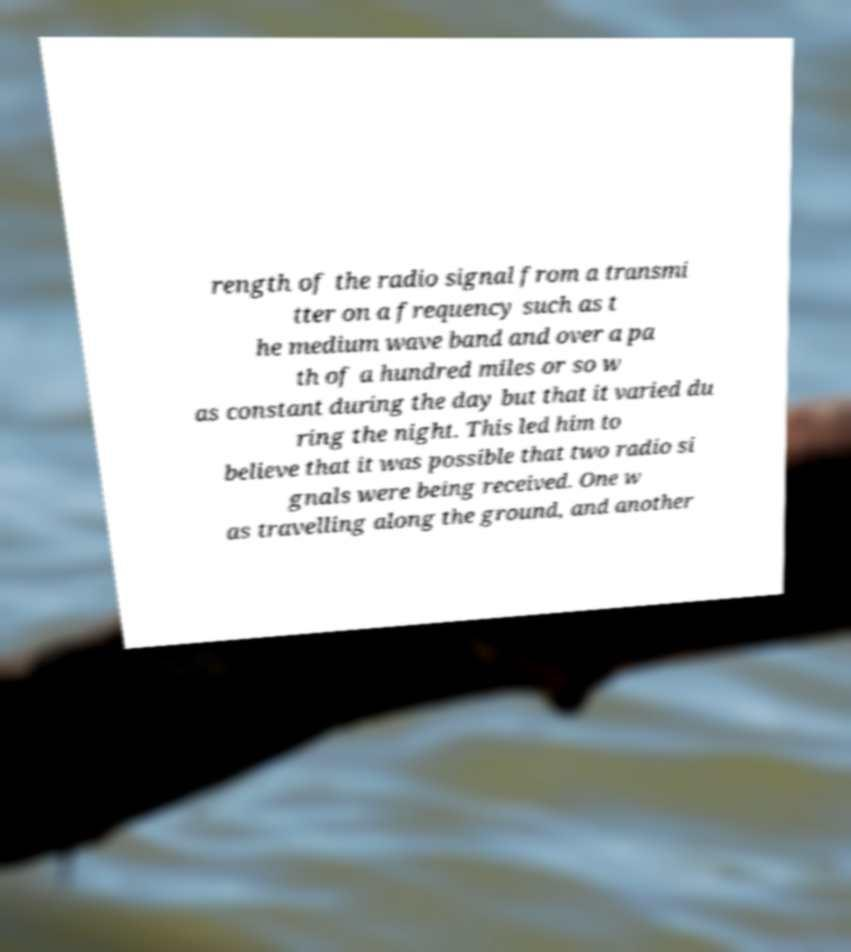Please identify and transcribe the text found in this image. rength of the radio signal from a transmi tter on a frequency such as t he medium wave band and over a pa th of a hundred miles or so w as constant during the day but that it varied du ring the night. This led him to believe that it was possible that two radio si gnals were being received. One w as travelling along the ground, and another 